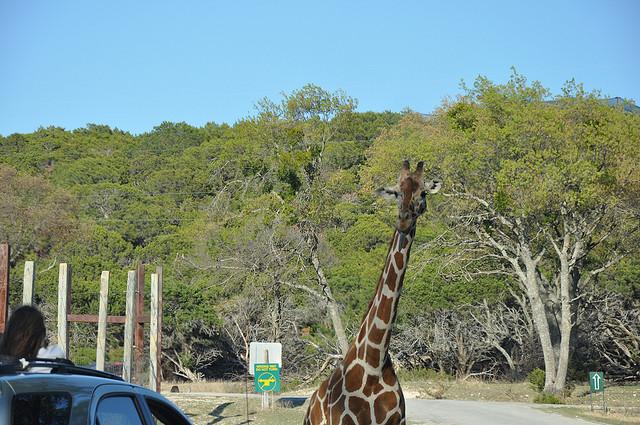Is the giraffe running away from the car?
Short answer required. No. What is cast?
Answer briefly. Giraffe. What does the sign on the right indicate?
Answer briefly. Straight. 